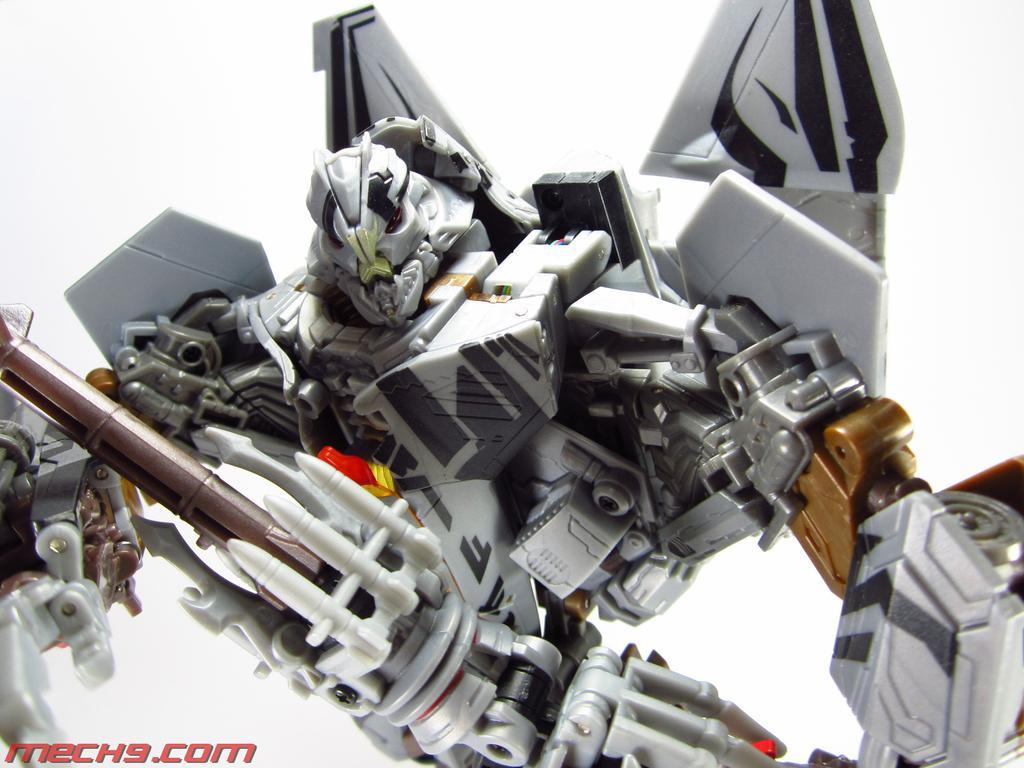Could you give a brief overview of what you see in this image? In this picture there is a toy. In the bottom left there is a text. At the back there is a white background. 